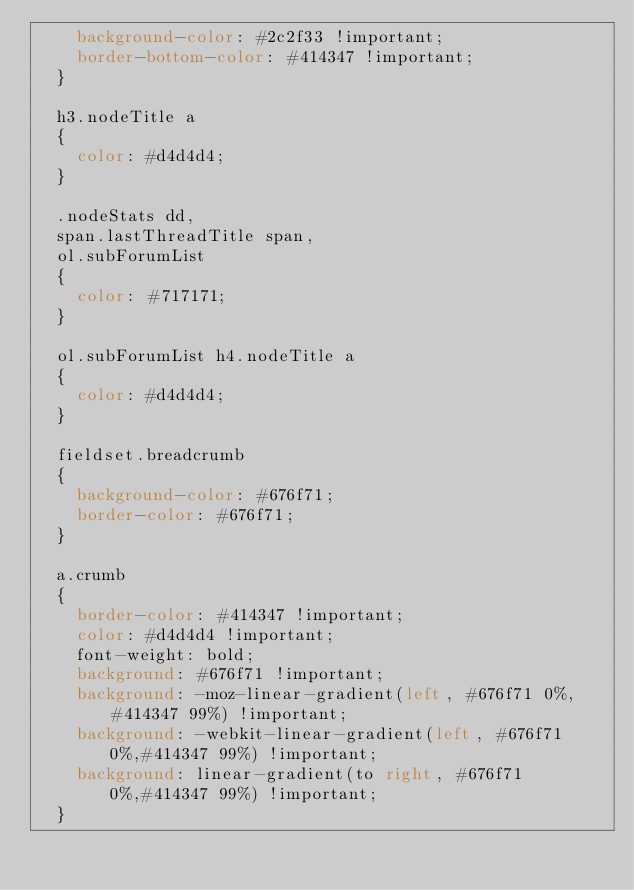<code> <loc_0><loc_0><loc_500><loc_500><_CSS_>    background-color: #2c2f33 !important;
    border-bottom-color: #414347 !important;
  }

  h3.nodeTitle a
  {
    color: #d4d4d4;
  }

  .nodeStats dd,
  span.lastThreadTitle span,
  ol.subForumList
  {
    color: #717171;
  }

  ol.subForumList h4.nodeTitle a
  {
    color: #d4d4d4;
  }

  fieldset.breadcrumb
  {
    background-color: #676f71;
    border-color: #676f71;
  }

  a.crumb
  {
    border-color: #414347 !important;
    color: #d4d4d4 !important;
    font-weight: bold;
    background: #676f71 !important;
    background: -moz-linear-gradient(left, #676f71 0%, #414347 99%) !important;
    background: -webkit-linear-gradient(left, #676f71 0%,#414347 99%) !important;
    background: linear-gradient(to right, #676f71 0%,#414347 99%) !important;
  }</code> 